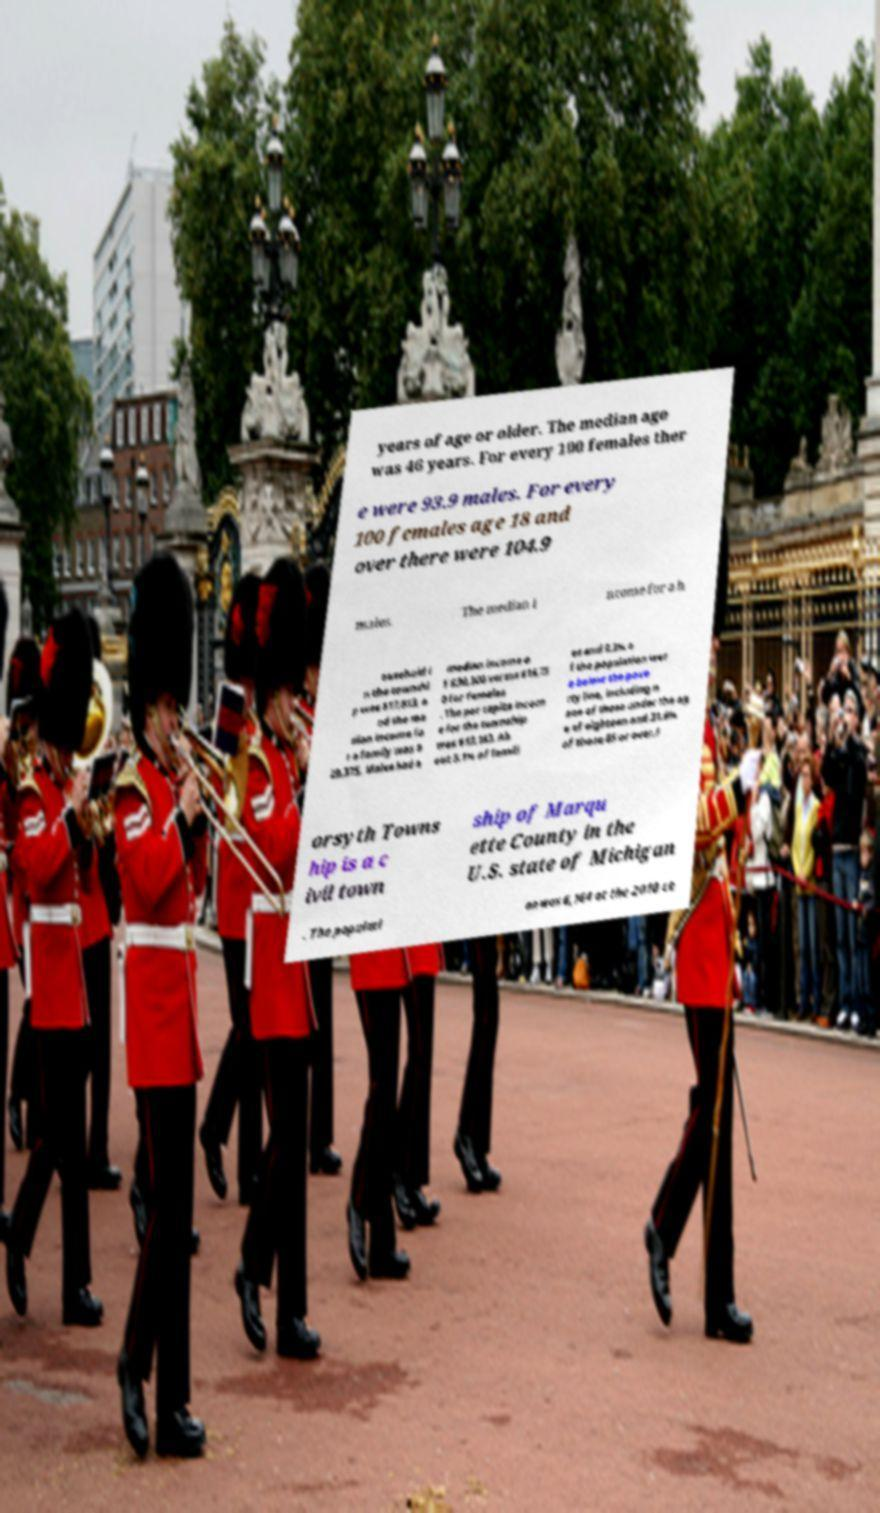For documentation purposes, I need the text within this image transcribed. Could you provide that? years of age or older. The median age was 46 years. For every 100 females ther e were 93.9 males. For every 100 females age 18 and over there were 104.9 males. The median i ncome for a h ousehold i n the townshi p was $17,813, a nd the me dian income fo r a family was $ 29,375. Males had a median income o f $30,500 versus $18,75 0 for females . The per capita incom e for the township was $13,183. Ab out 5.1% of famili es and 9.3% o f the population wer e below the pove rty line, including n one of those under the ag e of eighteen and 31.6% of those 65 or over.F orsyth Towns hip is a c ivil town ship of Marqu ette County in the U.S. state of Michigan . The populati on was 6,164 at the 2010 ce 